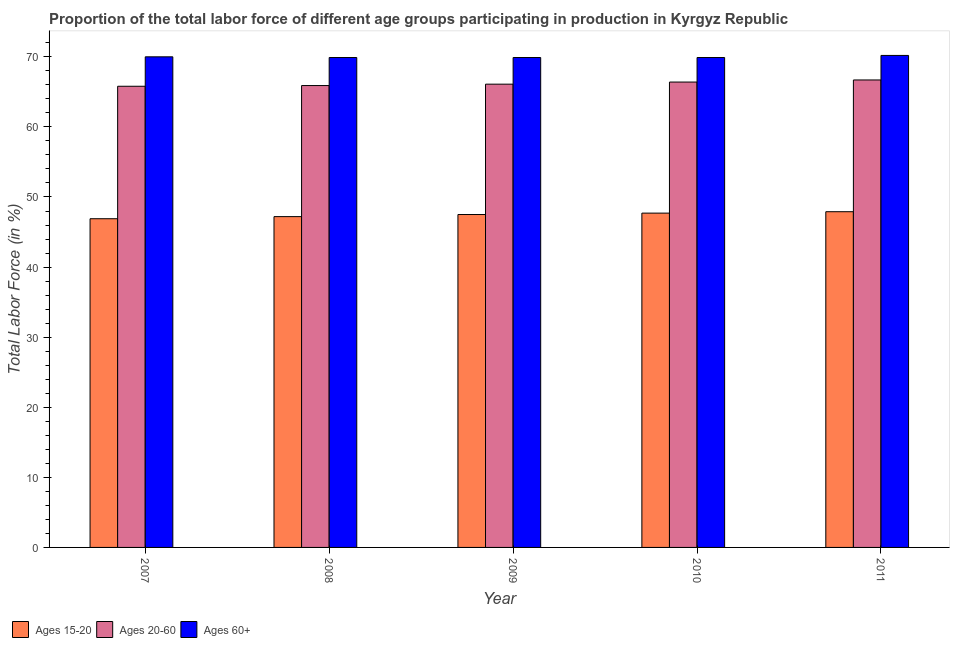How many different coloured bars are there?
Your answer should be very brief. 3. How many bars are there on the 2nd tick from the left?
Your answer should be compact. 3. What is the label of the 1st group of bars from the left?
Provide a short and direct response. 2007. In how many cases, is the number of bars for a given year not equal to the number of legend labels?
Make the answer very short. 0. What is the percentage of labor force within the age group 20-60 in 2008?
Make the answer very short. 65.9. Across all years, what is the maximum percentage of labor force within the age group 15-20?
Your response must be concise. 47.9. Across all years, what is the minimum percentage of labor force within the age group 20-60?
Your answer should be compact. 65.8. In which year was the percentage of labor force within the age group 15-20 maximum?
Provide a succinct answer. 2011. In which year was the percentage of labor force above age 60 minimum?
Keep it short and to the point. 2008. What is the total percentage of labor force within the age group 20-60 in the graph?
Offer a terse response. 330.9. What is the difference between the percentage of labor force within the age group 20-60 in 2007 and that in 2011?
Give a very brief answer. -0.9. What is the difference between the percentage of labor force within the age group 15-20 in 2011 and the percentage of labor force above age 60 in 2008?
Your answer should be compact. 0.7. What is the average percentage of labor force within the age group 15-20 per year?
Offer a terse response. 47.44. What is the ratio of the percentage of labor force within the age group 15-20 in 2007 to that in 2011?
Your response must be concise. 0.98. Is the percentage of labor force within the age group 20-60 in 2008 less than that in 2009?
Provide a succinct answer. Yes. What is the difference between the highest and the second highest percentage of labor force within the age group 20-60?
Your answer should be compact. 0.3. What is the difference between the highest and the lowest percentage of labor force above age 60?
Provide a succinct answer. 0.3. In how many years, is the percentage of labor force within the age group 20-60 greater than the average percentage of labor force within the age group 20-60 taken over all years?
Your response must be concise. 2. Is the sum of the percentage of labor force above age 60 in 2008 and 2010 greater than the maximum percentage of labor force within the age group 20-60 across all years?
Provide a succinct answer. Yes. What does the 1st bar from the left in 2010 represents?
Make the answer very short. Ages 15-20. What does the 3rd bar from the right in 2009 represents?
Your answer should be very brief. Ages 15-20. How many bars are there?
Offer a very short reply. 15. Are all the bars in the graph horizontal?
Offer a terse response. No. How many years are there in the graph?
Your answer should be compact. 5. Does the graph contain any zero values?
Make the answer very short. No. How many legend labels are there?
Keep it short and to the point. 3. How are the legend labels stacked?
Offer a terse response. Horizontal. What is the title of the graph?
Your response must be concise. Proportion of the total labor force of different age groups participating in production in Kyrgyz Republic. What is the label or title of the X-axis?
Keep it short and to the point. Year. What is the Total Labor Force (in %) of Ages 15-20 in 2007?
Provide a short and direct response. 46.9. What is the Total Labor Force (in %) of Ages 20-60 in 2007?
Your answer should be compact. 65.8. What is the Total Labor Force (in %) of Ages 60+ in 2007?
Provide a succinct answer. 70. What is the Total Labor Force (in %) in Ages 15-20 in 2008?
Ensure brevity in your answer.  47.2. What is the Total Labor Force (in %) in Ages 20-60 in 2008?
Provide a short and direct response. 65.9. What is the Total Labor Force (in %) in Ages 60+ in 2008?
Offer a terse response. 69.9. What is the Total Labor Force (in %) in Ages 15-20 in 2009?
Your response must be concise. 47.5. What is the Total Labor Force (in %) in Ages 20-60 in 2009?
Provide a short and direct response. 66.1. What is the Total Labor Force (in %) of Ages 60+ in 2009?
Offer a terse response. 69.9. What is the Total Labor Force (in %) in Ages 15-20 in 2010?
Provide a short and direct response. 47.7. What is the Total Labor Force (in %) in Ages 20-60 in 2010?
Provide a short and direct response. 66.4. What is the Total Labor Force (in %) in Ages 60+ in 2010?
Your answer should be very brief. 69.9. What is the Total Labor Force (in %) in Ages 15-20 in 2011?
Give a very brief answer. 47.9. What is the Total Labor Force (in %) in Ages 20-60 in 2011?
Your answer should be very brief. 66.7. What is the Total Labor Force (in %) in Ages 60+ in 2011?
Your answer should be compact. 70.2. Across all years, what is the maximum Total Labor Force (in %) in Ages 15-20?
Your answer should be very brief. 47.9. Across all years, what is the maximum Total Labor Force (in %) of Ages 20-60?
Make the answer very short. 66.7. Across all years, what is the maximum Total Labor Force (in %) in Ages 60+?
Your answer should be compact. 70.2. Across all years, what is the minimum Total Labor Force (in %) in Ages 15-20?
Ensure brevity in your answer.  46.9. Across all years, what is the minimum Total Labor Force (in %) of Ages 20-60?
Give a very brief answer. 65.8. Across all years, what is the minimum Total Labor Force (in %) of Ages 60+?
Ensure brevity in your answer.  69.9. What is the total Total Labor Force (in %) in Ages 15-20 in the graph?
Your answer should be very brief. 237.2. What is the total Total Labor Force (in %) in Ages 20-60 in the graph?
Provide a succinct answer. 330.9. What is the total Total Labor Force (in %) in Ages 60+ in the graph?
Your response must be concise. 349.9. What is the difference between the Total Labor Force (in %) in Ages 20-60 in 2007 and that in 2008?
Your answer should be very brief. -0.1. What is the difference between the Total Labor Force (in %) of Ages 60+ in 2007 and that in 2008?
Give a very brief answer. 0.1. What is the difference between the Total Labor Force (in %) in Ages 15-20 in 2007 and that in 2009?
Give a very brief answer. -0.6. What is the difference between the Total Labor Force (in %) in Ages 20-60 in 2007 and that in 2009?
Your answer should be compact. -0.3. What is the difference between the Total Labor Force (in %) in Ages 15-20 in 2007 and that in 2010?
Provide a short and direct response. -0.8. What is the difference between the Total Labor Force (in %) in Ages 20-60 in 2007 and that in 2010?
Keep it short and to the point. -0.6. What is the difference between the Total Labor Force (in %) of Ages 60+ in 2007 and that in 2010?
Provide a short and direct response. 0.1. What is the difference between the Total Labor Force (in %) in Ages 15-20 in 2007 and that in 2011?
Your answer should be very brief. -1. What is the difference between the Total Labor Force (in %) of Ages 20-60 in 2008 and that in 2009?
Your answer should be compact. -0.2. What is the difference between the Total Labor Force (in %) in Ages 60+ in 2008 and that in 2010?
Offer a very short reply. 0. What is the difference between the Total Labor Force (in %) in Ages 15-20 in 2008 and that in 2011?
Provide a short and direct response. -0.7. What is the difference between the Total Labor Force (in %) of Ages 20-60 in 2008 and that in 2011?
Ensure brevity in your answer.  -0.8. What is the difference between the Total Labor Force (in %) of Ages 20-60 in 2009 and that in 2010?
Your answer should be very brief. -0.3. What is the difference between the Total Labor Force (in %) in Ages 60+ in 2009 and that in 2010?
Keep it short and to the point. 0. What is the difference between the Total Labor Force (in %) of Ages 20-60 in 2009 and that in 2011?
Your answer should be very brief. -0.6. What is the difference between the Total Labor Force (in %) in Ages 60+ in 2009 and that in 2011?
Your answer should be compact. -0.3. What is the difference between the Total Labor Force (in %) of Ages 15-20 in 2010 and that in 2011?
Provide a short and direct response. -0.2. What is the difference between the Total Labor Force (in %) in Ages 15-20 in 2007 and the Total Labor Force (in %) in Ages 20-60 in 2008?
Provide a succinct answer. -19. What is the difference between the Total Labor Force (in %) of Ages 15-20 in 2007 and the Total Labor Force (in %) of Ages 20-60 in 2009?
Your answer should be very brief. -19.2. What is the difference between the Total Labor Force (in %) of Ages 20-60 in 2007 and the Total Labor Force (in %) of Ages 60+ in 2009?
Your answer should be compact. -4.1. What is the difference between the Total Labor Force (in %) of Ages 15-20 in 2007 and the Total Labor Force (in %) of Ages 20-60 in 2010?
Offer a terse response. -19.5. What is the difference between the Total Labor Force (in %) in Ages 15-20 in 2007 and the Total Labor Force (in %) in Ages 60+ in 2010?
Provide a succinct answer. -23. What is the difference between the Total Labor Force (in %) of Ages 15-20 in 2007 and the Total Labor Force (in %) of Ages 20-60 in 2011?
Provide a short and direct response. -19.8. What is the difference between the Total Labor Force (in %) in Ages 15-20 in 2007 and the Total Labor Force (in %) in Ages 60+ in 2011?
Provide a short and direct response. -23.3. What is the difference between the Total Labor Force (in %) in Ages 15-20 in 2008 and the Total Labor Force (in %) in Ages 20-60 in 2009?
Your answer should be compact. -18.9. What is the difference between the Total Labor Force (in %) in Ages 15-20 in 2008 and the Total Labor Force (in %) in Ages 60+ in 2009?
Give a very brief answer. -22.7. What is the difference between the Total Labor Force (in %) in Ages 15-20 in 2008 and the Total Labor Force (in %) in Ages 20-60 in 2010?
Provide a short and direct response. -19.2. What is the difference between the Total Labor Force (in %) of Ages 15-20 in 2008 and the Total Labor Force (in %) of Ages 60+ in 2010?
Provide a succinct answer. -22.7. What is the difference between the Total Labor Force (in %) of Ages 20-60 in 2008 and the Total Labor Force (in %) of Ages 60+ in 2010?
Your response must be concise. -4. What is the difference between the Total Labor Force (in %) of Ages 15-20 in 2008 and the Total Labor Force (in %) of Ages 20-60 in 2011?
Offer a very short reply. -19.5. What is the difference between the Total Labor Force (in %) in Ages 15-20 in 2008 and the Total Labor Force (in %) in Ages 60+ in 2011?
Provide a succinct answer. -23. What is the difference between the Total Labor Force (in %) in Ages 15-20 in 2009 and the Total Labor Force (in %) in Ages 20-60 in 2010?
Your answer should be compact. -18.9. What is the difference between the Total Labor Force (in %) in Ages 15-20 in 2009 and the Total Labor Force (in %) in Ages 60+ in 2010?
Your answer should be very brief. -22.4. What is the difference between the Total Labor Force (in %) of Ages 15-20 in 2009 and the Total Labor Force (in %) of Ages 20-60 in 2011?
Your answer should be compact. -19.2. What is the difference between the Total Labor Force (in %) of Ages 15-20 in 2009 and the Total Labor Force (in %) of Ages 60+ in 2011?
Your answer should be very brief. -22.7. What is the difference between the Total Labor Force (in %) of Ages 20-60 in 2009 and the Total Labor Force (in %) of Ages 60+ in 2011?
Your answer should be compact. -4.1. What is the difference between the Total Labor Force (in %) in Ages 15-20 in 2010 and the Total Labor Force (in %) in Ages 60+ in 2011?
Your answer should be very brief. -22.5. What is the average Total Labor Force (in %) in Ages 15-20 per year?
Keep it short and to the point. 47.44. What is the average Total Labor Force (in %) in Ages 20-60 per year?
Your answer should be compact. 66.18. What is the average Total Labor Force (in %) of Ages 60+ per year?
Provide a succinct answer. 69.98. In the year 2007, what is the difference between the Total Labor Force (in %) of Ages 15-20 and Total Labor Force (in %) of Ages 20-60?
Keep it short and to the point. -18.9. In the year 2007, what is the difference between the Total Labor Force (in %) of Ages 15-20 and Total Labor Force (in %) of Ages 60+?
Offer a very short reply. -23.1. In the year 2007, what is the difference between the Total Labor Force (in %) of Ages 20-60 and Total Labor Force (in %) of Ages 60+?
Give a very brief answer. -4.2. In the year 2008, what is the difference between the Total Labor Force (in %) of Ages 15-20 and Total Labor Force (in %) of Ages 20-60?
Provide a succinct answer. -18.7. In the year 2008, what is the difference between the Total Labor Force (in %) of Ages 15-20 and Total Labor Force (in %) of Ages 60+?
Offer a terse response. -22.7. In the year 2008, what is the difference between the Total Labor Force (in %) of Ages 20-60 and Total Labor Force (in %) of Ages 60+?
Your answer should be very brief. -4. In the year 2009, what is the difference between the Total Labor Force (in %) in Ages 15-20 and Total Labor Force (in %) in Ages 20-60?
Provide a succinct answer. -18.6. In the year 2009, what is the difference between the Total Labor Force (in %) of Ages 15-20 and Total Labor Force (in %) of Ages 60+?
Ensure brevity in your answer.  -22.4. In the year 2010, what is the difference between the Total Labor Force (in %) in Ages 15-20 and Total Labor Force (in %) in Ages 20-60?
Ensure brevity in your answer.  -18.7. In the year 2010, what is the difference between the Total Labor Force (in %) of Ages 15-20 and Total Labor Force (in %) of Ages 60+?
Ensure brevity in your answer.  -22.2. In the year 2010, what is the difference between the Total Labor Force (in %) in Ages 20-60 and Total Labor Force (in %) in Ages 60+?
Your answer should be compact. -3.5. In the year 2011, what is the difference between the Total Labor Force (in %) of Ages 15-20 and Total Labor Force (in %) of Ages 20-60?
Your answer should be compact. -18.8. In the year 2011, what is the difference between the Total Labor Force (in %) of Ages 15-20 and Total Labor Force (in %) of Ages 60+?
Offer a very short reply. -22.3. In the year 2011, what is the difference between the Total Labor Force (in %) of Ages 20-60 and Total Labor Force (in %) of Ages 60+?
Your answer should be very brief. -3.5. What is the ratio of the Total Labor Force (in %) in Ages 60+ in 2007 to that in 2008?
Provide a short and direct response. 1. What is the ratio of the Total Labor Force (in %) in Ages 15-20 in 2007 to that in 2009?
Offer a terse response. 0.99. What is the ratio of the Total Labor Force (in %) of Ages 15-20 in 2007 to that in 2010?
Offer a terse response. 0.98. What is the ratio of the Total Labor Force (in %) in Ages 20-60 in 2007 to that in 2010?
Offer a very short reply. 0.99. What is the ratio of the Total Labor Force (in %) of Ages 15-20 in 2007 to that in 2011?
Make the answer very short. 0.98. What is the ratio of the Total Labor Force (in %) in Ages 20-60 in 2007 to that in 2011?
Provide a short and direct response. 0.99. What is the ratio of the Total Labor Force (in %) in Ages 60+ in 2007 to that in 2011?
Make the answer very short. 1. What is the ratio of the Total Labor Force (in %) in Ages 15-20 in 2008 to that in 2009?
Offer a very short reply. 0.99. What is the ratio of the Total Labor Force (in %) of Ages 20-60 in 2008 to that in 2009?
Your answer should be very brief. 1. What is the ratio of the Total Labor Force (in %) in Ages 60+ in 2008 to that in 2010?
Your answer should be very brief. 1. What is the ratio of the Total Labor Force (in %) in Ages 15-20 in 2008 to that in 2011?
Your answer should be very brief. 0.99. What is the ratio of the Total Labor Force (in %) of Ages 15-20 in 2009 to that in 2010?
Make the answer very short. 1. What is the ratio of the Total Labor Force (in %) in Ages 20-60 in 2009 to that in 2010?
Offer a terse response. 1. What is the ratio of the Total Labor Force (in %) in Ages 60+ in 2009 to that in 2010?
Offer a terse response. 1. What is the ratio of the Total Labor Force (in %) of Ages 20-60 in 2009 to that in 2011?
Your response must be concise. 0.99. What is the ratio of the Total Labor Force (in %) in Ages 15-20 in 2010 to that in 2011?
Provide a short and direct response. 1. What is the difference between the highest and the second highest Total Labor Force (in %) of Ages 60+?
Give a very brief answer. 0.2. What is the difference between the highest and the lowest Total Labor Force (in %) in Ages 15-20?
Make the answer very short. 1. What is the difference between the highest and the lowest Total Labor Force (in %) of Ages 20-60?
Ensure brevity in your answer.  0.9. 